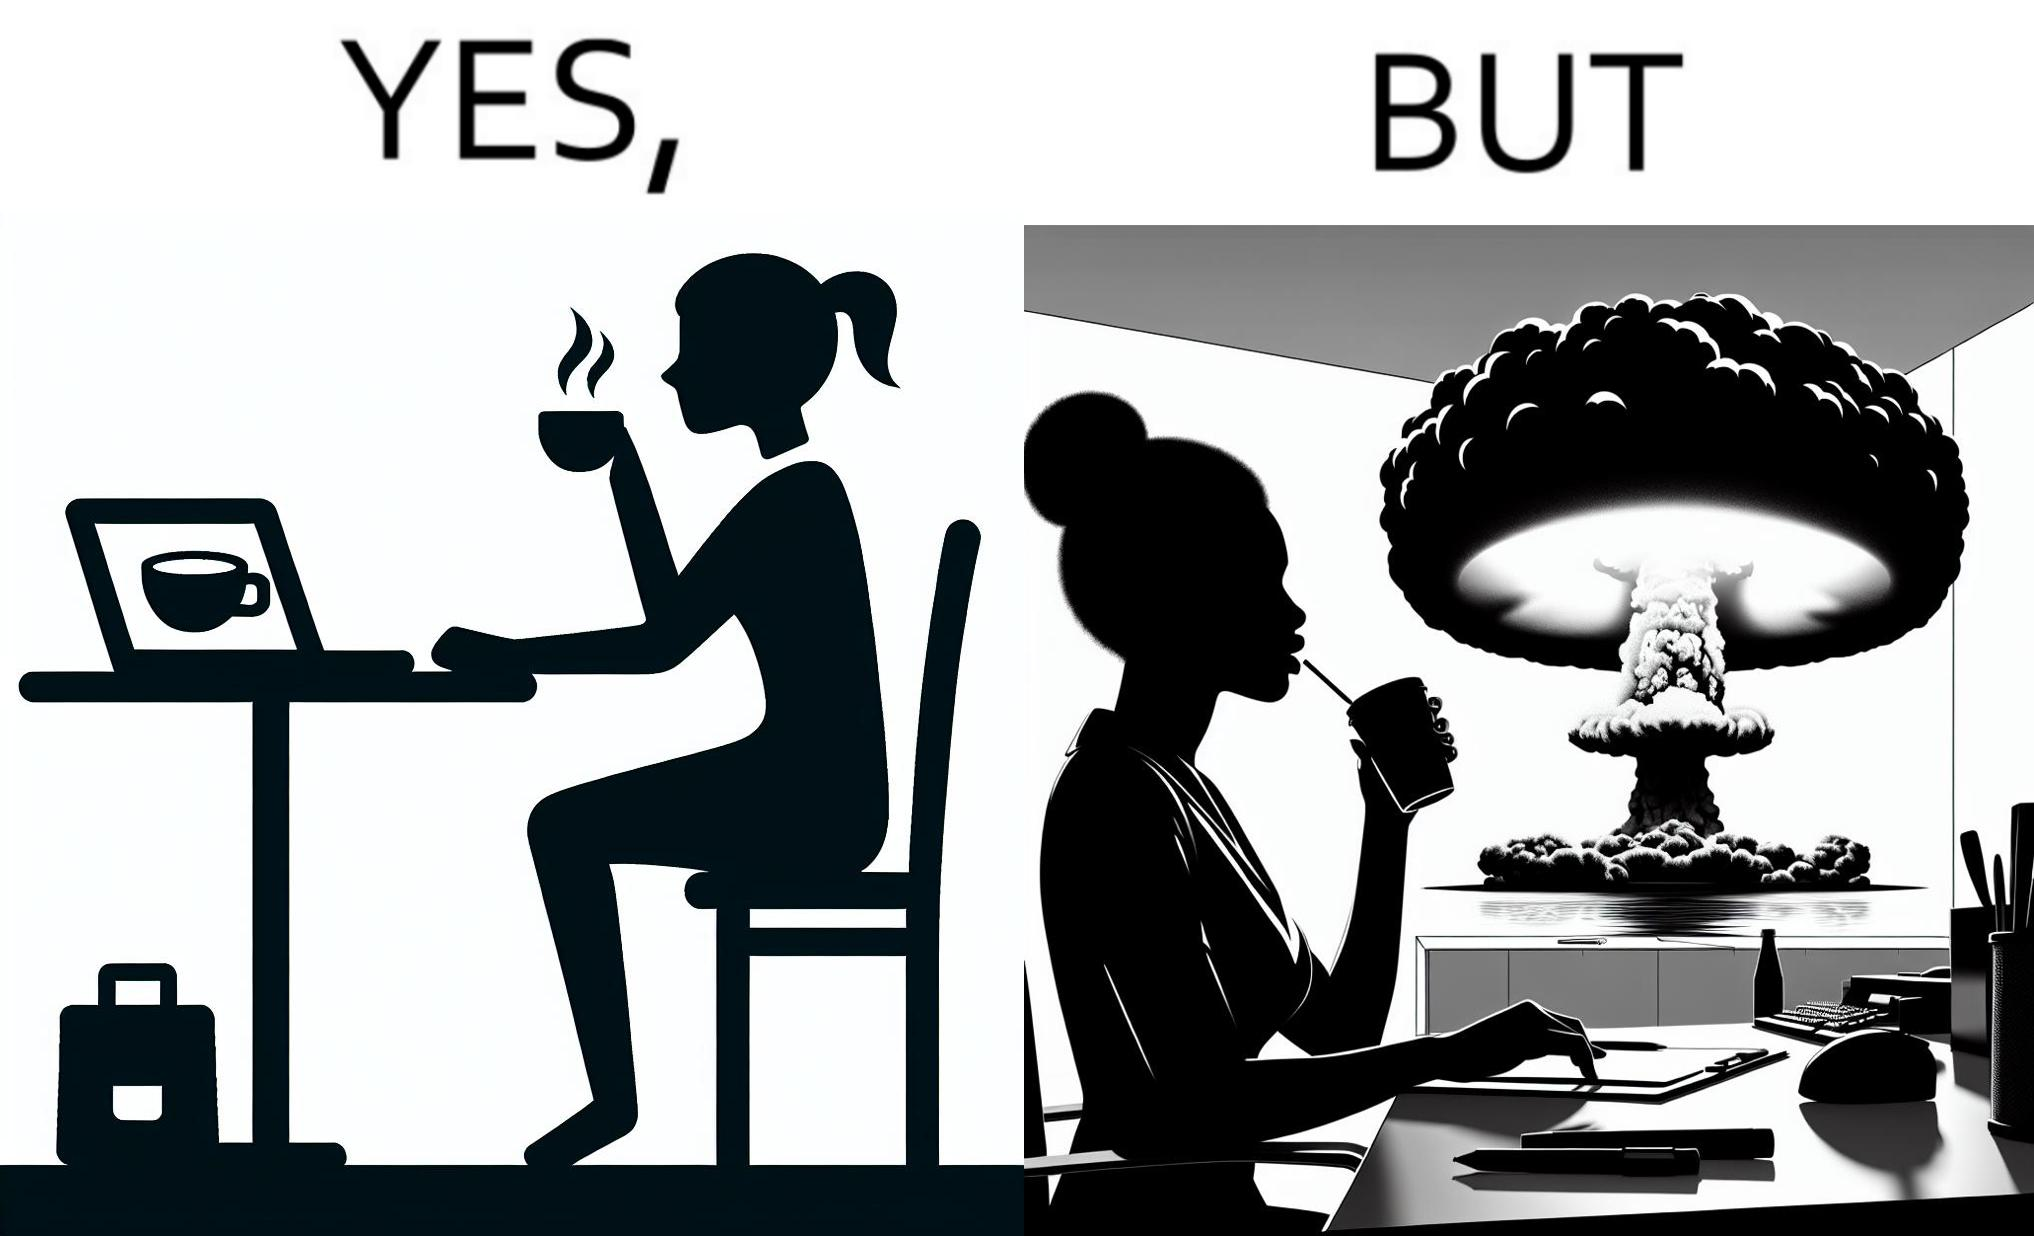Describe the contrast between the left and right parts of this image. In the left part of the image: A woman sipping from a cup in a cafe with her laptop In the right part of the image: A woman sipping from a cup while looking at a nuclear blast from her desk 